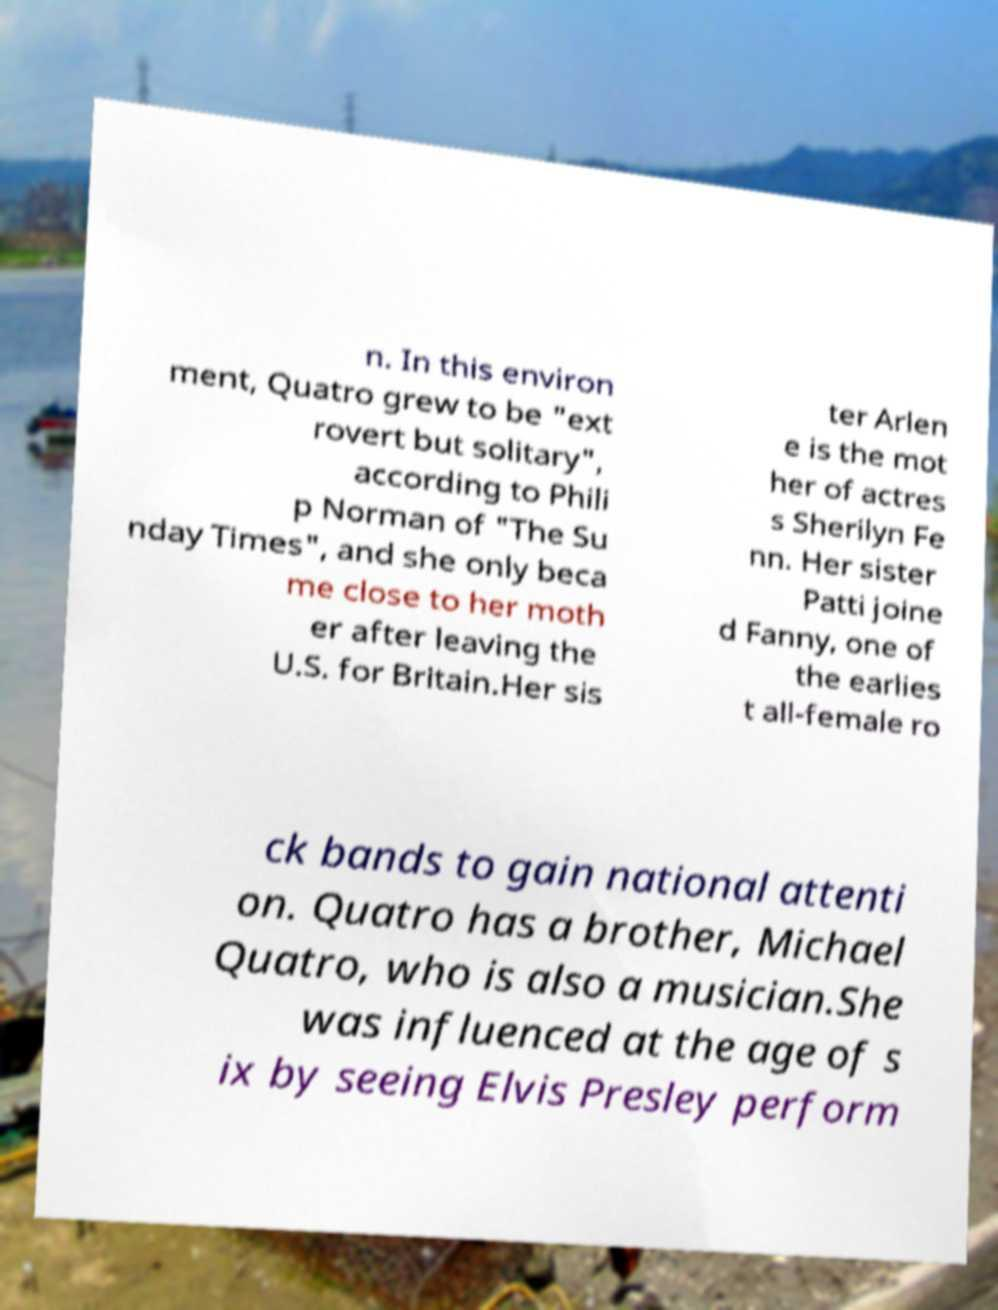Can you accurately transcribe the text from the provided image for me? n. In this environ ment, Quatro grew to be "ext rovert but solitary", according to Phili p Norman of "The Su nday Times", and she only beca me close to her moth er after leaving the U.S. for Britain.Her sis ter Arlen e is the mot her of actres s Sherilyn Fe nn. Her sister Patti joine d Fanny, one of the earlies t all-female ro ck bands to gain national attenti on. Quatro has a brother, Michael Quatro, who is also a musician.She was influenced at the age of s ix by seeing Elvis Presley perform 